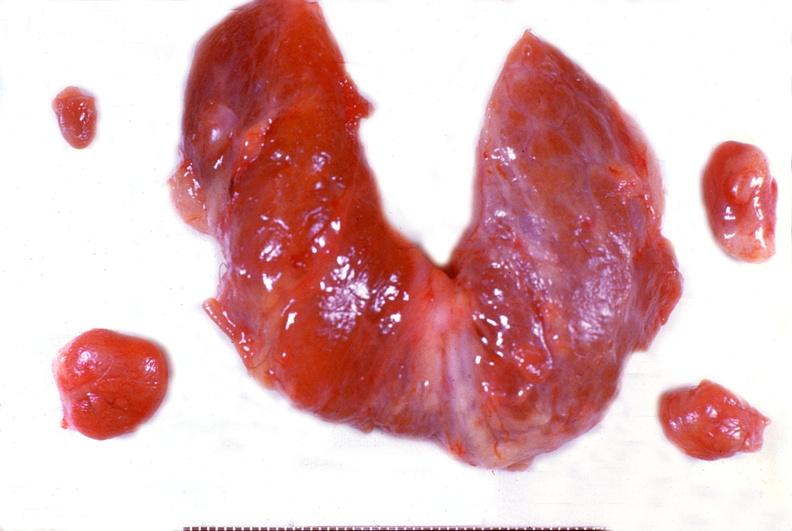where does this belong to?
Answer the question using a single word or phrase. Endocrine system 